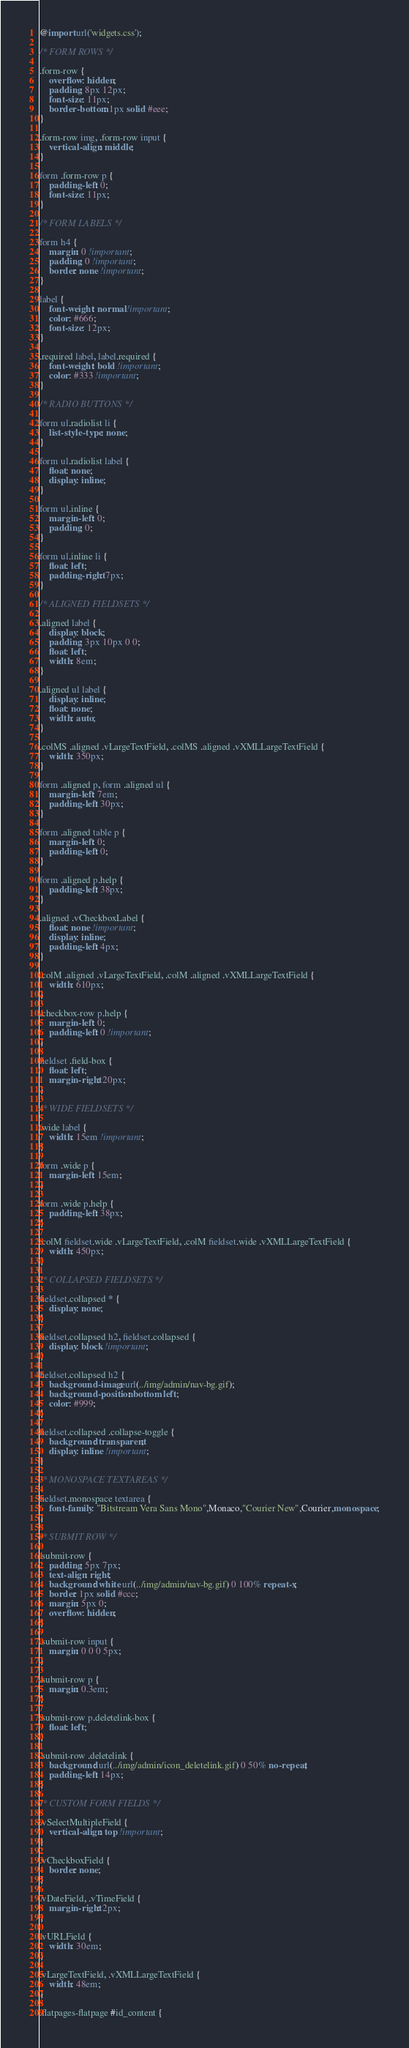<code> <loc_0><loc_0><loc_500><loc_500><_CSS_>@import url('widgets.css');

/* FORM ROWS */

.form-row {
    overflow: hidden;
    padding: 8px 12px;
    font-size: 11px;
    border-bottom: 1px solid #eee;
}

.form-row img, .form-row input {
    vertical-align: middle;
}

form .form-row p {
    padding-left: 0;
    font-size: 11px;
}

/* FORM LABELS */

form h4 {
    margin: 0 !important;
    padding: 0 !important;
    border: none !important;
}

label {
    font-weight: normal !important;
    color: #666;
    font-size: 12px;
}

.required label, label.required {
    font-weight: bold !important;
    color: #333 !important;
}

/* RADIO BUTTONS */

form ul.radiolist li {
    list-style-type: none;
}

form ul.radiolist label {
    float: none;
    display: inline;
}

form ul.inline {
    margin-left: 0;
    padding: 0;
}

form ul.inline li {
    float: left;
    padding-right: 7px;
}

/* ALIGNED FIELDSETS */

.aligned label {
    display: block;
    padding: 3px 10px 0 0;
    float: left;
    width: 8em;
}

.aligned ul label {
    display: inline;
    float: none;
    width: auto;
}

.colMS .aligned .vLargeTextField, .colMS .aligned .vXMLLargeTextField {
    width: 350px;
}

form .aligned p, form .aligned ul {
    margin-left: 7em;
    padding-left: 30px;
}

form .aligned table p {
    margin-left: 0;
    padding-left: 0;
}

form .aligned p.help {
    padding-left: 38px;
}

.aligned .vCheckboxLabel {
    float: none !important;
    display: inline;
    padding-left: 4px;
}

.colM .aligned .vLargeTextField, .colM .aligned .vXMLLargeTextField {
    width: 610px;
}

.checkbox-row p.help {
    margin-left: 0;
    padding-left: 0 !important;
}

fieldset .field-box {
    float: left;
    margin-right: 20px;
}

/* WIDE FIELDSETS */

.wide label {
    width: 15em !important;
}

form .wide p {
    margin-left: 15em;
}

form .wide p.help {
    padding-left: 38px;
}

.colM fieldset.wide .vLargeTextField, .colM fieldset.wide .vXMLLargeTextField {
    width: 450px;
}

/* COLLAPSED FIELDSETS */

fieldset.collapsed * {
    display: none;
}

fieldset.collapsed h2, fieldset.collapsed {
    display: block !important;
}

fieldset.collapsed h2 {
    background-image: url(../img/admin/nav-bg.gif);
    background-position: bottom left;
    color: #999;
}

fieldset.collapsed .collapse-toggle {
    background: transparent;
    display: inline !important;
}

/* MONOSPACE TEXTAREAS */

fieldset.monospace textarea {
    font-family: "Bitstream Vera Sans Mono",Monaco,"Courier New",Courier,monospace;
}

/* SUBMIT ROW */

.submit-row {
    padding: 5px 7px;
    text-align: right;
    background: white url(../img/admin/nav-bg.gif) 0 100% repeat-x;
    border: 1px solid #ccc;
    margin: 5px 0;
    overflow: hidden;
}

.submit-row input {
    margin: 0 0 0 5px;
}

.submit-row p {
    margin: 0.3em;
}

.submit-row p.deletelink-box {
    float: left;
}

.submit-row .deletelink {
    background: url(../img/admin/icon_deletelink.gif) 0 50% no-repeat;
    padding-left: 14px;
}

/* CUSTOM FORM FIELDS */

.vSelectMultipleField {
    vertical-align: top !important;
}

.vCheckboxField {
    border: none;
}

.vDateField, .vTimeField {
    margin-right: 2px;
}

.vURLField {
    width: 30em;
}

.vLargeTextField, .vXMLLargeTextField {
    width: 48em;
}

.flatpages-flatpage #id_content {</code> 